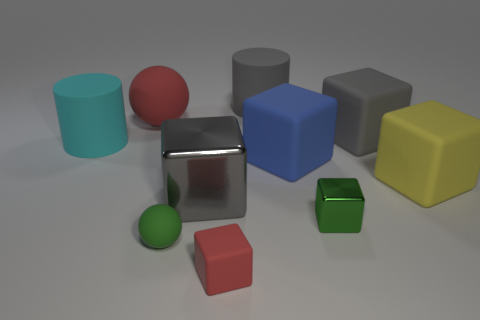Subtract all red rubber cubes. How many cubes are left? 5 Subtract all yellow cubes. How many cubes are left? 5 Subtract all spheres. How many objects are left? 8 Subtract all brown balls. Subtract all gray cylinders. How many balls are left? 2 Subtract all red balls. How many gray cubes are left? 2 Subtract all large objects. Subtract all big yellow rubber objects. How many objects are left? 2 Add 4 cyan matte objects. How many cyan matte objects are left? 5 Add 9 cyan metal cylinders. How many cyan metal cylinders exist? 9 Subtract 1 green cubes. How many objects are left? 9 Subtract 2 balls. How many balls are left? 0 